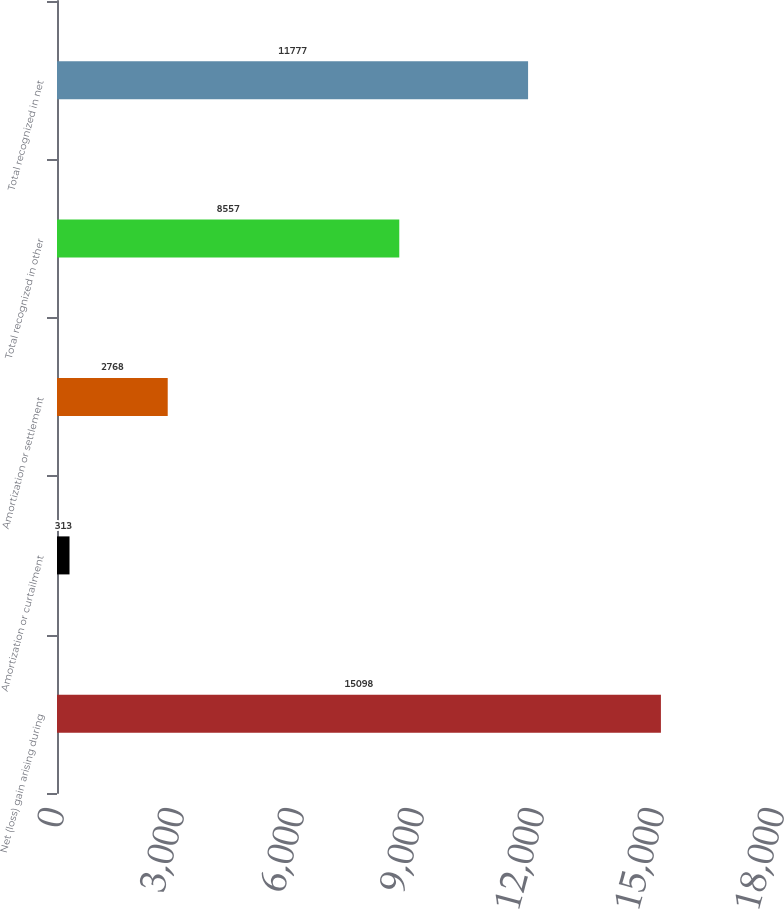Convert chart to OTSL. <chart><loc_0><loc_0><loc_500><loc_500><bar_chart><fcel>Net (loss) gain arising during<fcel>Amortization or curtailment<fcel>Amortization or settlement<fcel>Total recognized in other<fcel>Total recognized in net<nl><fcel>15098<fcel>313<fcel>2768<fcel>8557<fcel>11777<nl></chart> 